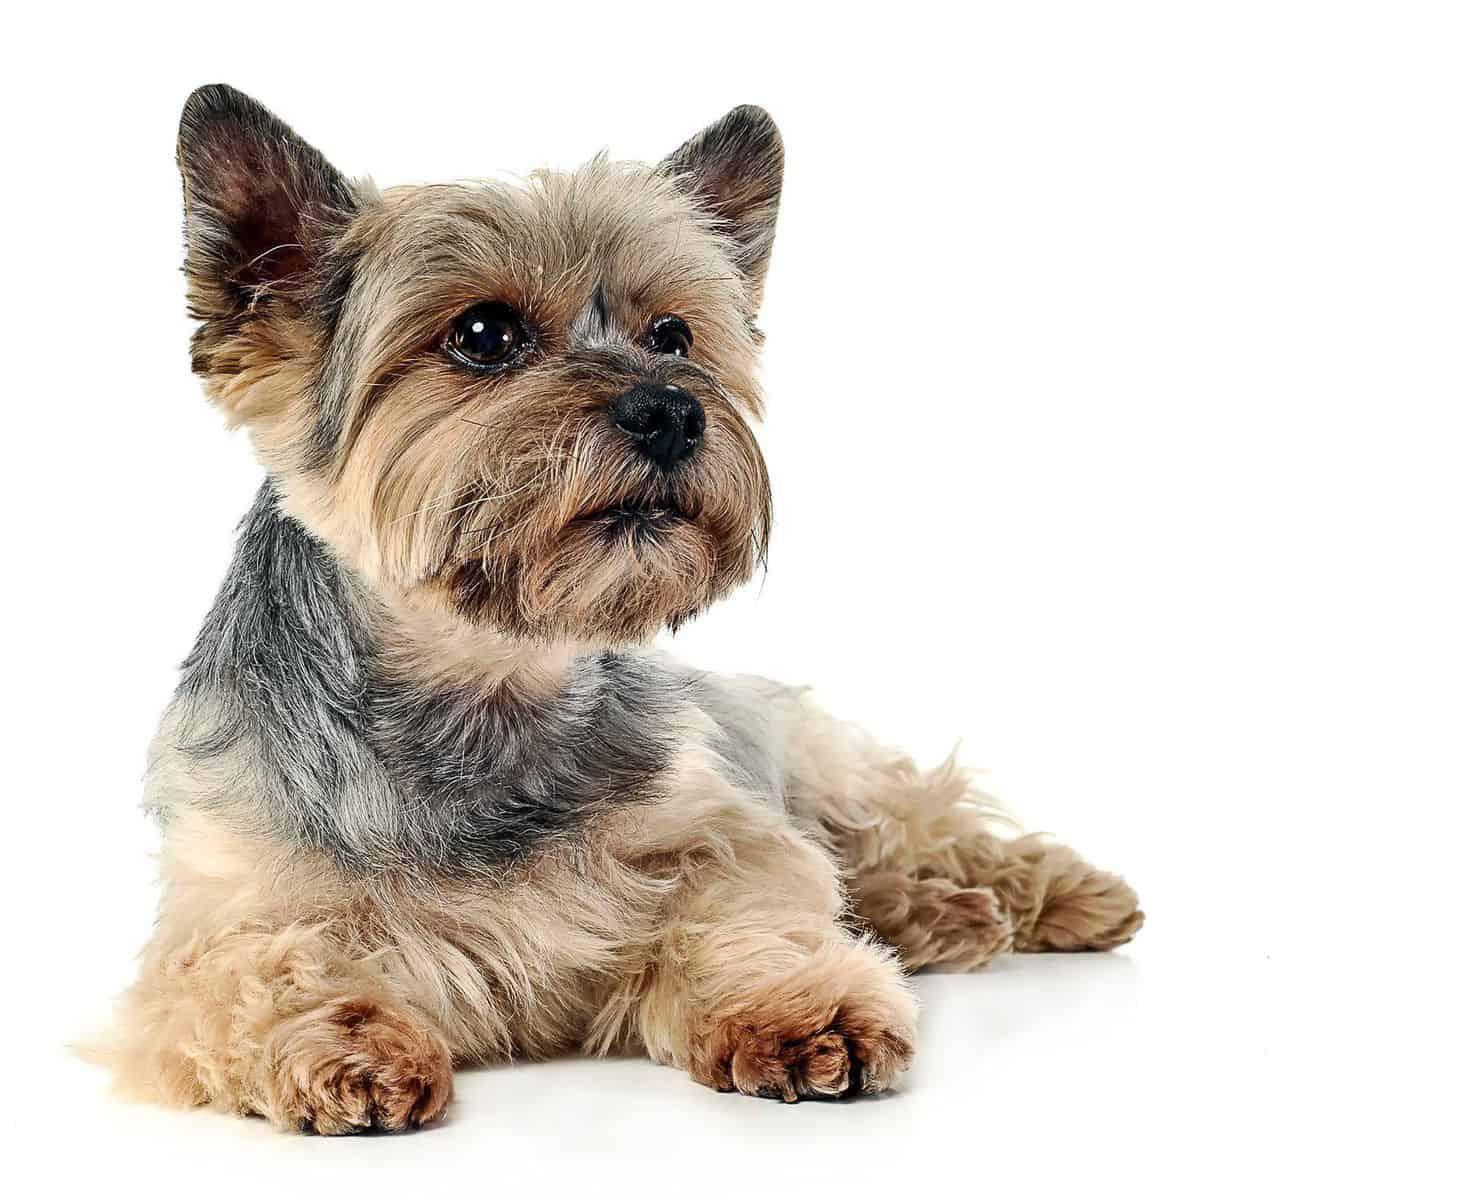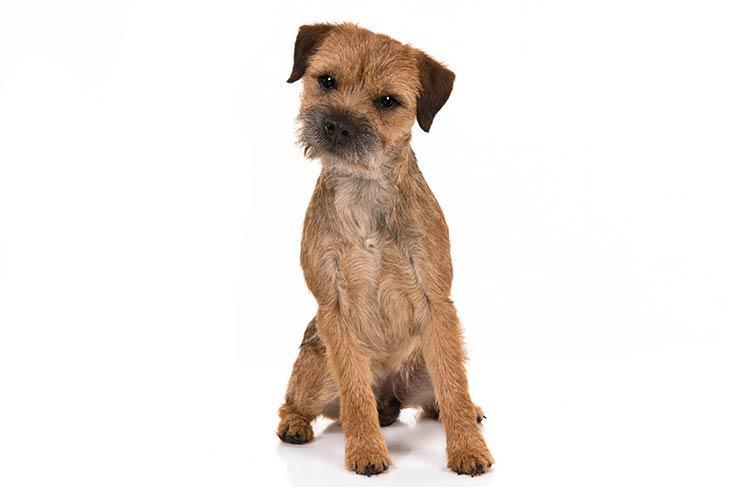The first image is the image on the left, the second image is the image on the right. Analyze the images presented: Is the assertion "The left and right image contains the same number of dogs with at least one of them sitting." valid? Answer yes or no. Yes. The first image is the image on the left, the second image is the image on the right. For the images shown, is this caption "A dog is laying down." true? Answer yes or no. Yes. 